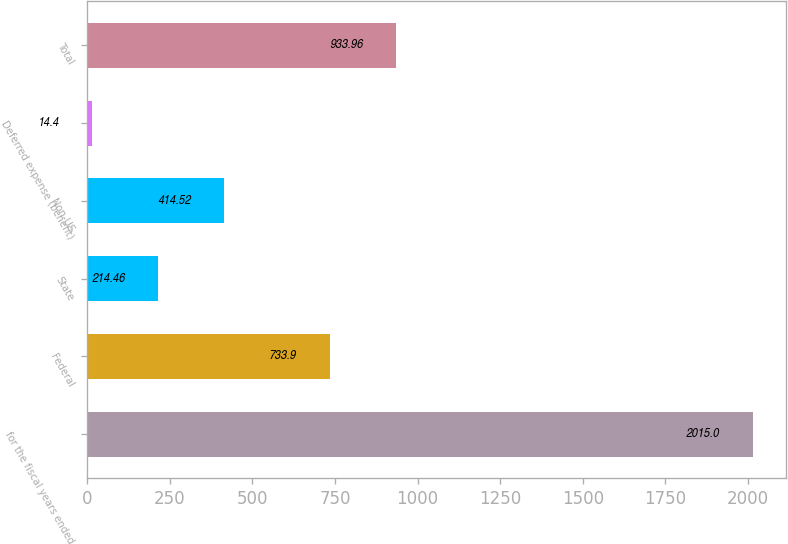<chart> <loc_0><loc_0><loc_500><loc_500><bar_chart><fcel>for the fiscal years ended<fcel>Federal<fcel>State<fcel>Non-US<fcel>Deferred expense (benefit)<fcel>Total<nl><fcel>2015<fcel>733.9<fcel>214.46<fcel>414.52<fcel>14.4<fcel>933.96<nl></chart> 